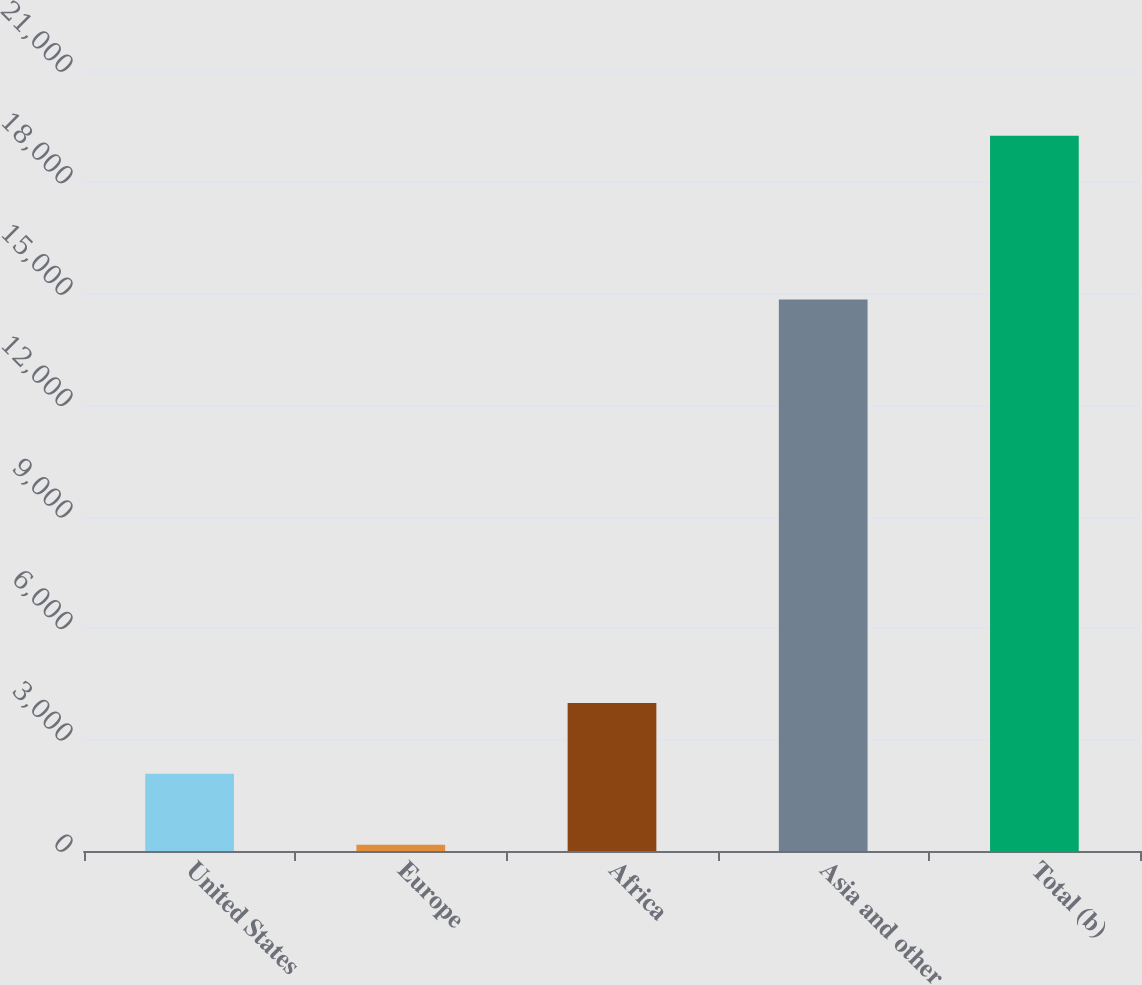<chart> <loc_0><loc_0><loc_500><loc_500><bar_chart><fcel>United States<fcel>Europe<fcel>Africa<fcel>Asia and other<fcel>Total (b)<nl><fcel>2077.8<fcel>169<fcel>3986.6<fcel>14845<fcel>19257<nl></chart> 